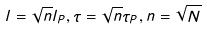Convert formula to latex. <formula><loc_0><loc_0><loc_500><loc_500>l = \sqrt { n } l _ { P } , \tau = \sqrt { n } \tau _ { P } , n = \sqrt { N }</formula> 